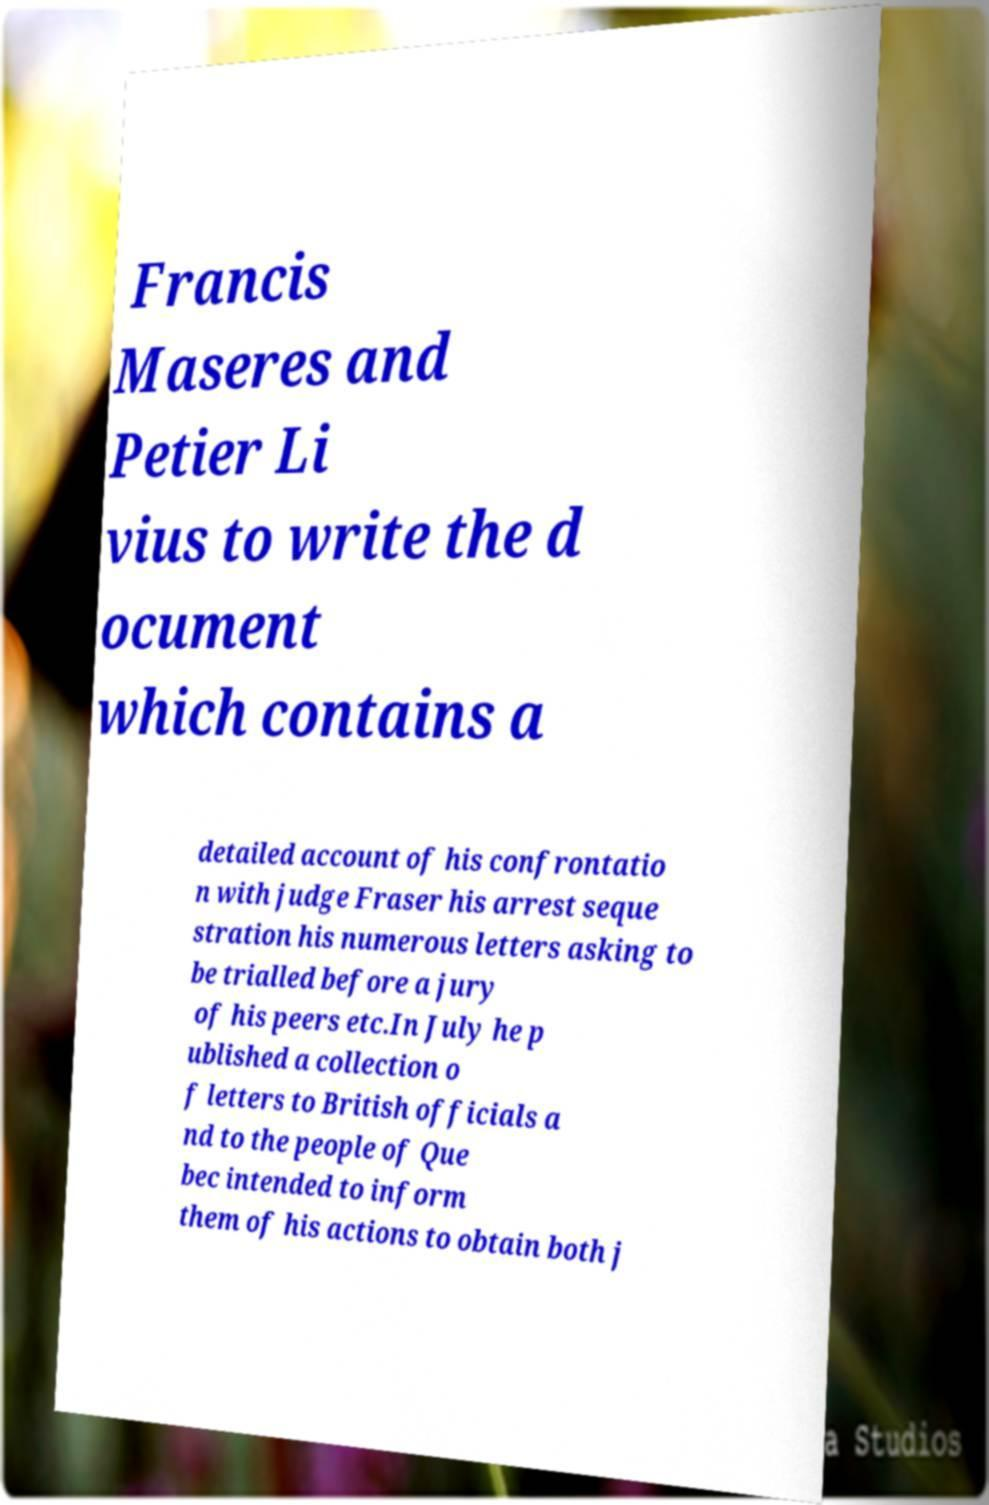Could you assist in decoding the text presented in this image and type it out clearly? Francis Maseres and Petier Li vius to write the d ocument which contains a detailed account of his confrontatio n with judge Fraser his arrest seque stration his numerous letters asking to be trialled before a jury of his peers etc.In July he p ublished a collection o f letters to British officials a nd to the people of Que bec intended to inform them of his actions to obtain both j 